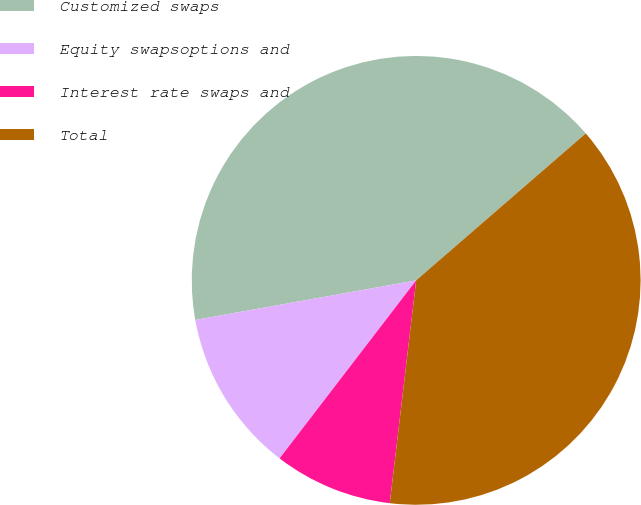Convert chart. <chart><loc_0><loc_0><loc_500><loc_500><pie_chart><fcel>Customized swaps<fcel>Equity swapsoptions and<fcel>Interest rate swaps and<fcel>Total<nl><fcel>41.46%<fcel>11.76%<fcel>8.54%<fcel>38.24%<nl></chart> 